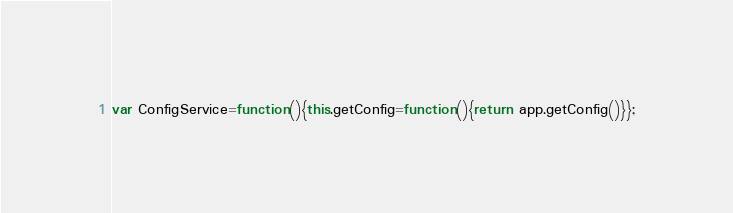<code> <loc_0><loc_0><loc_500><loc_500><_JavaScript_>var ConfigService=function(){this.getConfig=function(){return app.getConfig()}};</code> 